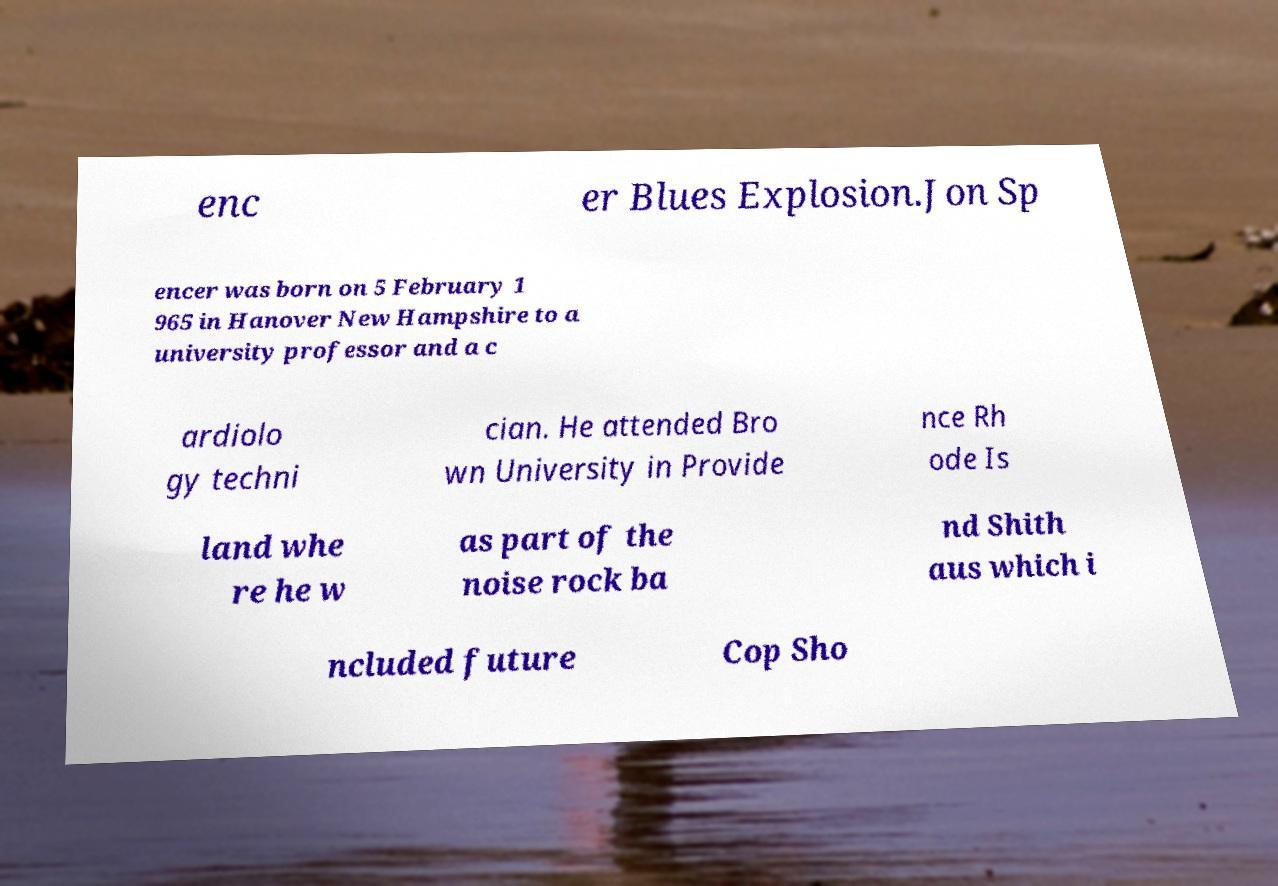Can you read and provide the text displayed in the image?This photo seems to have some interesting text. Can you extract and type it out for me? enc er Blues Explosion.Jon Sp encer was born on 5 February 1 965 in Hanover New Hampshire to a university professor and a c ardiolo gy techni cian. He attended Bro wn University in Provide nce Rh ode Is land whe re he w as part of the noise rock ba nd Shith aus which i ncluded future Cop Sho 